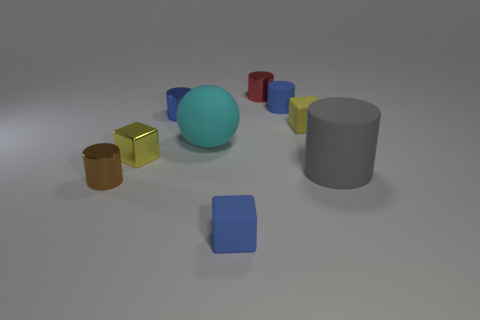Subtract all brown cylinders. How many cylinders are left? 4 Subtract all blue shiny cylinders. How many cylinders are left? 4 Subtract all purple cylinders. Subtract all cyan cubes. How many cylinders are left? 5 Add 1 big cyan rubber things. How many objects exist? 10 Subtract all blocks. How many objects are left? 6 Subtract 0 gray cubes. How many objects are left? 9 Subtract all small metallic blocks. Subtract all gray cylinders. How many objects are left? 7 Add 7 metal blocks. How many metal blocks are left? 8 Add 5 blue matte blocks. How many blue matte blocks exist? 6 